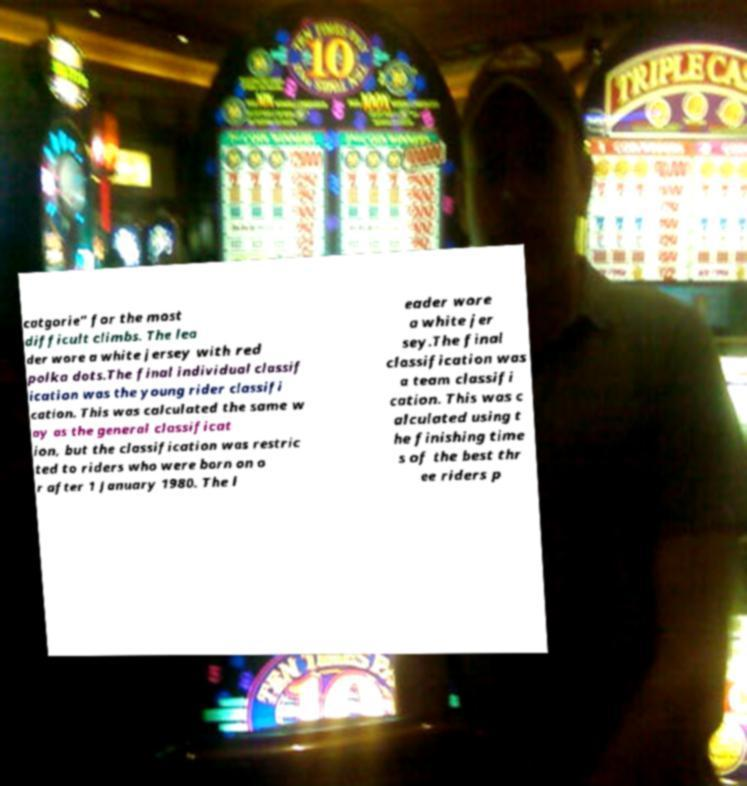Please identify and transcribe the text found in this image. catgorie" for the most difficult climbs. The lea der wore a white jersey with red polka dots.The final individual classif ication was the young rider classifi cation. This was calculated the same w ay as the general classificat ion, but the classification was restric ted to riders who were born on o r after 1 January 1980. The l eader wore a white jer sey.The final classification was a team classifi cation. This was c alculated using t he finishing time s of the best thr ee riders p 